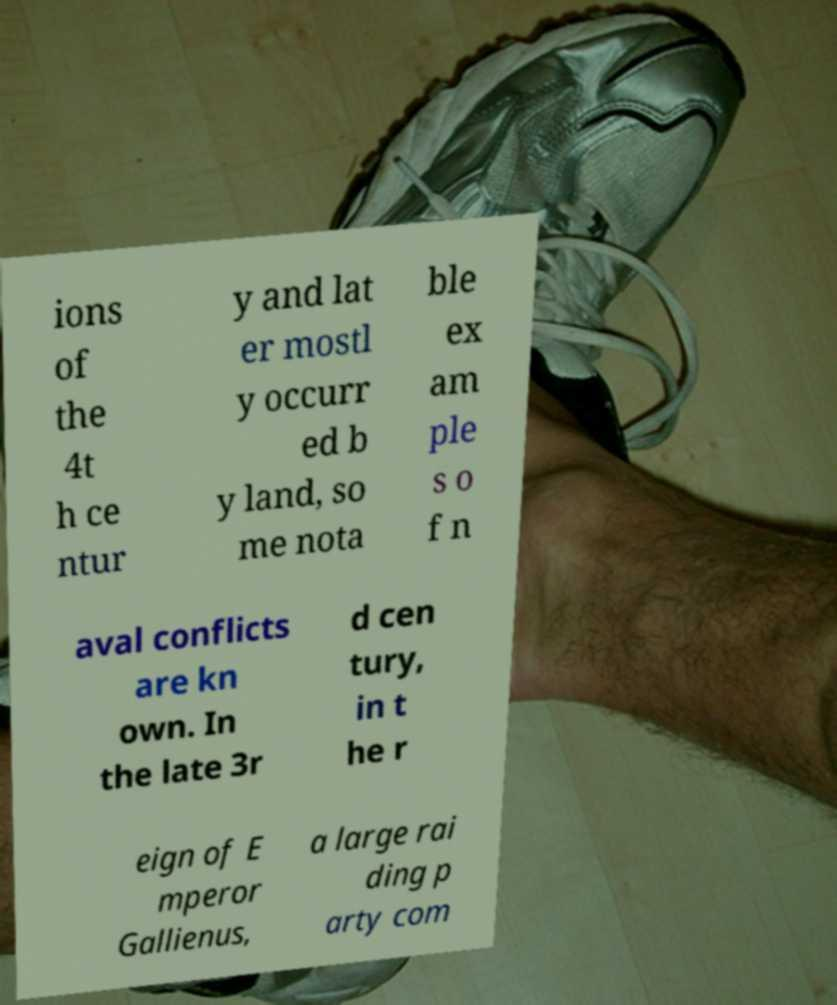Could you extract and type out the text from this image? ions of the 4t h ce ntur y and lat er mostl y occurr ed b y land, so me nota ble ex am ple s o f n aval conflicts are kn own. In the late 3r d cen tury, in t he r eign of E mperor Gallienus, a large rai ding p arty com 